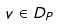<formula> <loc_0><loc_0><loc_500><loc_500>v \in D _ { P }</formula> 